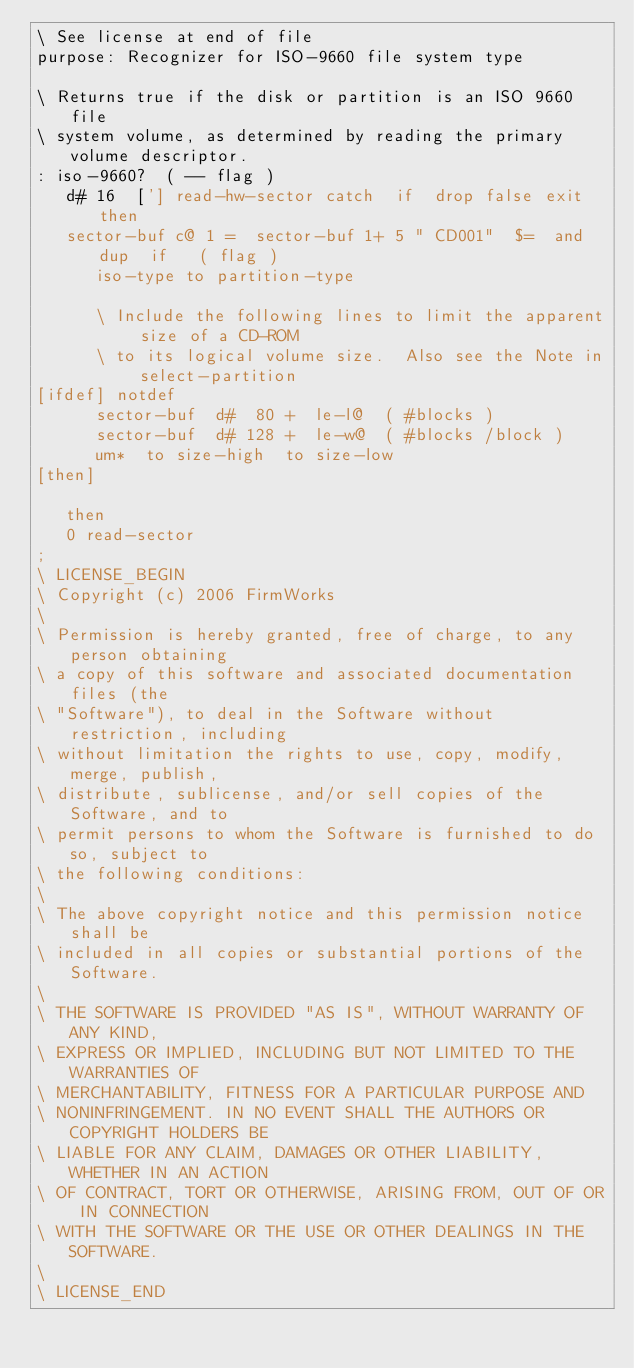Convert code to text. <code><loc_0><loc_0><loc_500><loc_500><_Forth_>\ See license at end of file
purpose: Recognizer for ISO-9660 file system type

\ Returns true if the disk or partition is an ISO 9660 file
\ system volume, as determined by reading the primary volume descriptor.
: iso-9660?  ( -- flag )
   d# 16  ['] read-hw-sector catch  if  drop false exit  then
   sector-buf c@ 1 =  sector-buf 1+ 5 " CD001"  $=  and  dup  if   ( flag )
      iso-type to partition-type

      \ Include the following lines to limit the apparent size of a CD-ROM
      \ to its logical volume size.  Also see the Note in select-partition
[ifdef] notdef
      sector-buf  d#  80 +  le-l@  ( #blocks )
      sector-buf  d# 128 +  le-w@  ( #blocks /block )
      um*  to size-high  to size-low
[then]

   then
   0 read-sector
;
\ LICENSE_BEGIN
\ Copyright (c) 2006 FirmWorks
\ 
\ Permission is hereby granted, free of charge, to any person obtaining
\ a copy of this software and associated documentation files (the
\ "Software"), to deal in the Software without restriction, including
\ without limitation the rights to use, copy, modify, merge, publish,
\ distribute, sublicense, and/or sell copies of the Software, and to
\ permit persons to whom the Software is furnished to do so, subject to
\ the following conditions:
\ 
\ The above copyright notice and this permission notice shall be
\ included in all copies or substantial portions of the Software.
\ 
\ THE SOFTWARE IS PROVIDED "AS IS", WITHOUT WARRANTY OF ANY KIND,
\ EXPRESS OR IMPLIED, INCLUDING BUT NOT LIMITED TO THE WARRANTIES OF
\ MERCHANTABILITY, FITNESS FOR A PARTICULAR PURPOSE AND
\ NONINFRINGEMENT. IN NO EVENT SHALL THE AUTHORS OR COPYRIGHT HOLDERS BE
\ LIABLE FOR ANY CLAIM, DAMAGES OR OTHER LIABILITY, WHETHER IN AN ACTION
\ OF CONTRACT, TORT OR OTHERWISE, ARISING FROM, OUT OF OR IN CONNECTION
\ WITH THE SOFTWARE OR THE USE OR OTHER DEALINGS IN THE SOFTWARE.
\
\ LICENSE_END
</code> 